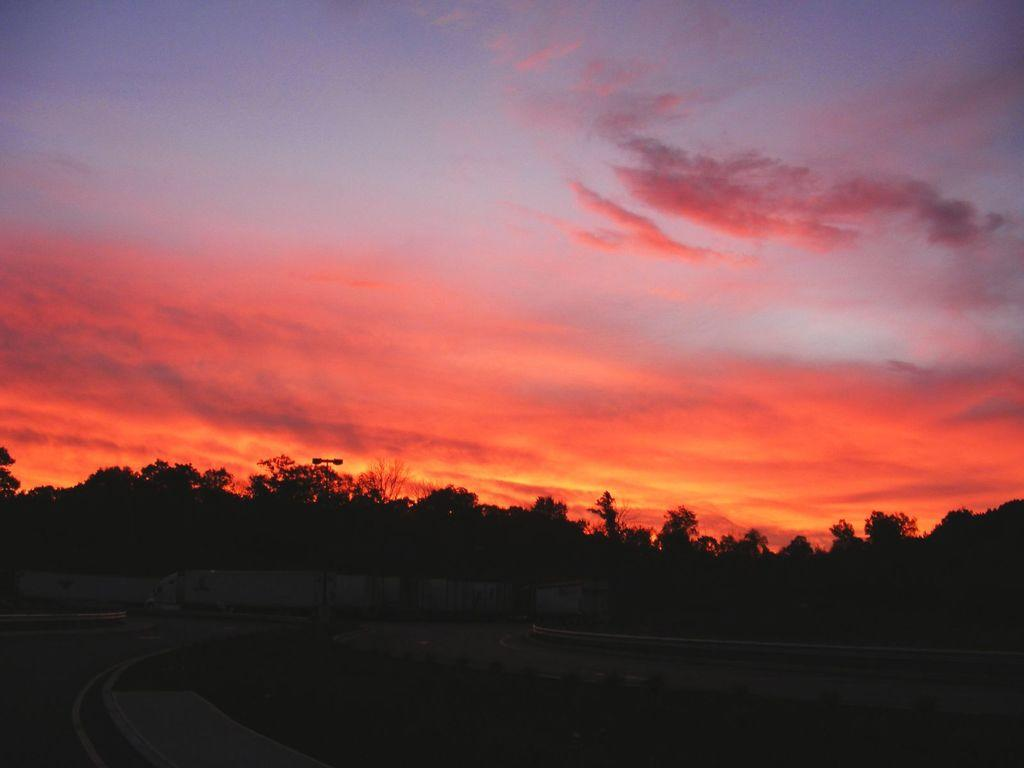What type of natural environment is visible in the background of the image? There are many trees in the background of the image. What can be seen in the front of the image? There appears to be a road in the front of the image. What is visible in the sky in the image? The sky is visible in the image, and clouds are present. Can you see an army of cooks preparing food on the road in the image? There is no army or cooks present in the image; it features a road with trees in the background and clouds in the sky. Are there any icicles hanging from the trees in the image? There are no icicles visible in the image; it is a scene with trees, a road, and clouds in the sky. 